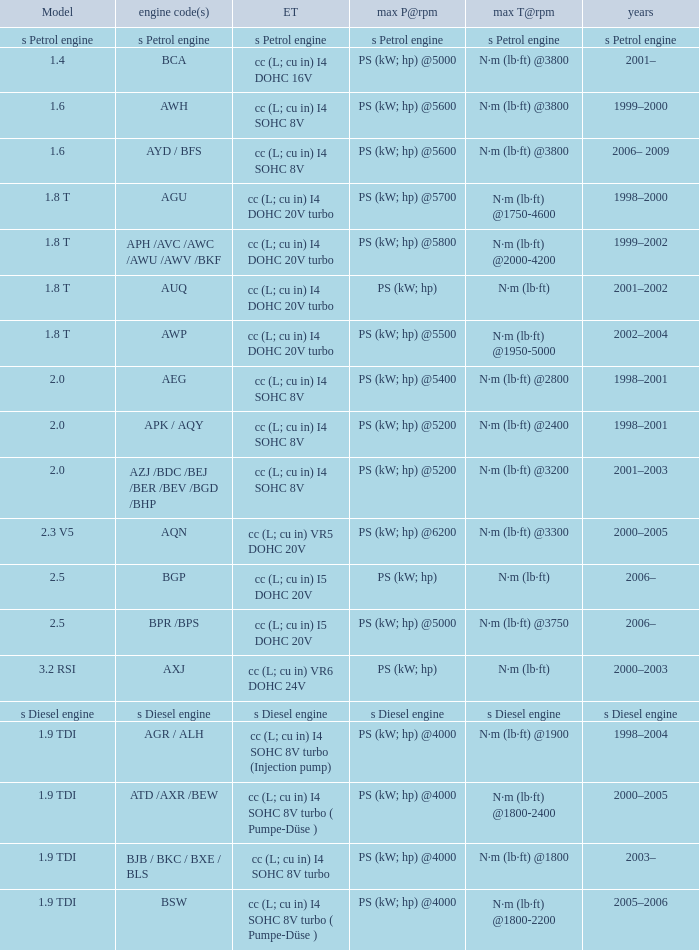Would you be able to parse every entry in this table? {'header': ['Model', 'engine code(s)', 'ET', 'max P@rpm', 'max T@rpm', 'years'], 'rows': [['s Petrol engine', 's Petrol engine', 's Petrol engine', 's Petrol engine', 's Petrol engine', 's Petrol engine'], ['1.4', 'BCA', 'cc (L; cu in) I4 DOHC 16V', 'PS (kW; hp) @5000', 'N·m (lb·ft) @3800', '2001–'], ['1.6', 'AWH', 'cc (L; cu in) I4 SOHC 8V', 'PS (kW; hp) @5600', 'N·m (lb·ft) @3800', '1999–2000'], ['1.6', 'AYD / BFS', 'cc (L; cu in) I4 SOHC 8V', 'PS (kW; hp) @5600', 'N·m (lb·ft) @3800', '2006– 2009'], ['1.8 T', 'AGU', 'cc (L; cu in) I4 DOHC 20V turbo', 'PS (kW; hp) @5700', 'N·m (lb·ft) @1750-4600', '1998–2000'], ['1.8 T', 'APH /AVC /AWC /AWU /AWV /BKF', 'cc (L; cu in) I4 DOHC 20V turbo', 'PS (kW; hp) @5800', 'N·m (lb·ft) @2000-4200', '1999–2002'], ['1.8 T', 'AUQ', 'cc (L; cu in) I4 DOHC 20V turbo', 'PS (kW; hp)', 'N·m (lb·ft)', '2001–2002'], ['1.8 T', 'AWP', 'cc (L; cu in) I4 DOHC 20V turbo', 'PS (kW; hp) @5500', 'N·m (lb·ft) @1950-5000', '2002–2004'], ['2.0', 'AEG', 'cc (L; cu in) I4 SOHC 8V', 'PS (kW; hp) @5400', 'N·m (lb·ft) @2800', '1998–2001'], ['2.0', 'APK / AQY', 'cc (L; cu in) I4 SOHC 8V', 'PS (kW; hp) @5200', 'N·m (lb·ft) @2400', '1998–2001'], ['2.0', 'AZJ /BDC /BEJ /BER /BEV /BGD /BHP', 'cc (L; cu in) I4 SOHC 8V', 'PS (kW; hp) @5200', 'N·m (lb·ft) @3200', '2001–2003'], ['2.3 V5', 'AQN', 'cc (L; cu in) VR5 DOHC 20V', 'PS (kW; hp) @6200', 'N·m (lb·ft) @3300', '2000–2005'], ['2.5', 'BGP', 'cc (L; cu in) I5 DOHC 20V', 'PS (kW; hp)', 'N·m (lb·ft)', '2006–'], ['2.5', 'BPR /BPS', 'cc (L; cu in) I5 DOHC 20V', 'PS (kW; hp) @5000', 'N·m (lb·ft) @3750', '2006–'], ['3.2 RSI', 'AXJ', 'cc (L; cu in) VR6 DOHC 24V', 'PS (kW; hp)', 'N·m (lb·ft)', '2000–2003'], ['s Diesel engine', 's Diesel engine', 's Diesel engine', 's Diesel engine', 's Diesel engine', 's Diesel engine'], ['1.9 TDI', 'AGR / ALH', 'cc (L; cu in) I4 SOHC 8V turbo (Injection pump)', 'PS (kW; hp) @4000', 'N·m (lb·ft) @1900', '1998–2004'], ['1.9 TDI', 'ATD /AXR /BEW', 'cc (L; cu in) I4 SOHC 8V turbo ( Pumpe-Düse )', 'PS (kW; hp) @4000', 'N·m (lb·ft) @1800-2400', '2000–2005'], ['1.9 TDI', 'BJB / BKC / BXE / BLS', 'cc (L; cu in) I4 SOHC 8V turbo', 'PS (kW; hp) @4000', 'N·m (lb·ft) @1800', '2003–'], ['1.9 TDI', 'BSW', 'cc (L; cu in) I4 SOHC 8V turbo ( Pumpe-Düse )', 'PS (kW; hp) @4000', 'N·m (lb·ft) @1800-2200', '2005–2006']]} Which engine type was used in the model 2.3 v5? Cc (l; cu in) vr5 dohc 20v. 